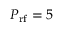<formula> <loc_0><loc_0><loc_500><loc_500>P _ { r f } = 5</formula> 